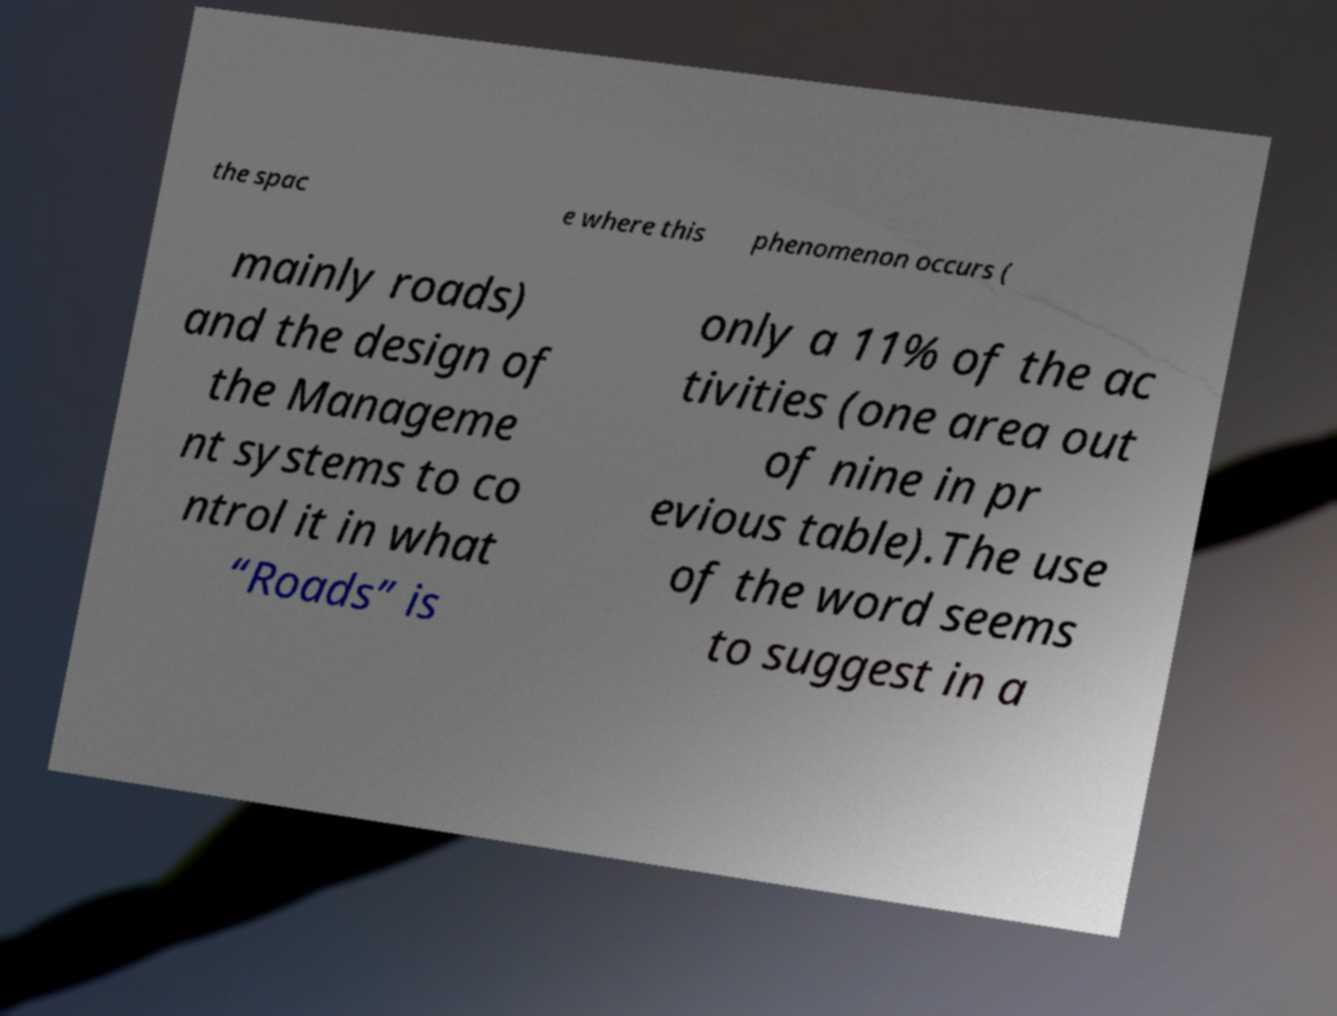Please read and relay the text visible in this image. What does it say? the spac e where this phenomenon occurs ( mainly roads) and the design of the Manageme nt systems to co ntrol it in what “Roads” is only a 11% of the ac tivities (one area out of nine in pr evious table).The use of the word seems to suggest in a 